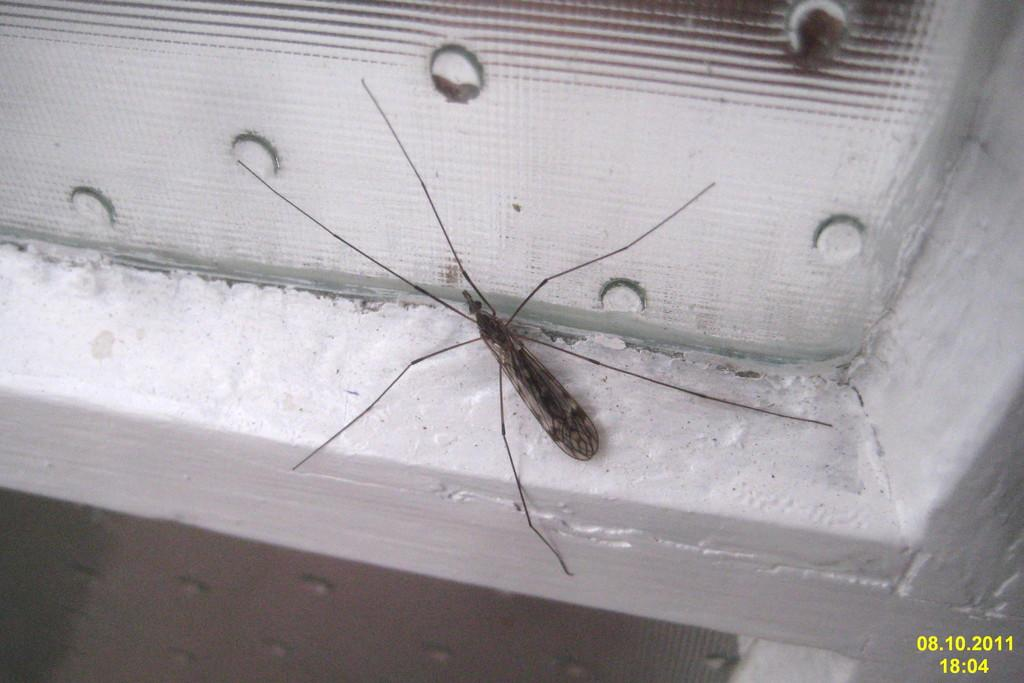What is the main subject in the foreground of the image? There is an insect in the foreground of the image. What type of surface is the insect on? The insect is on a wooden surface. Can you describe the wooden surface in the image? The wooden surface appears to be a window. How many mice are involved in the fight in the image? There are no mice or fights present in the image; it features an insect on a wooden surface that appears to be a window. 